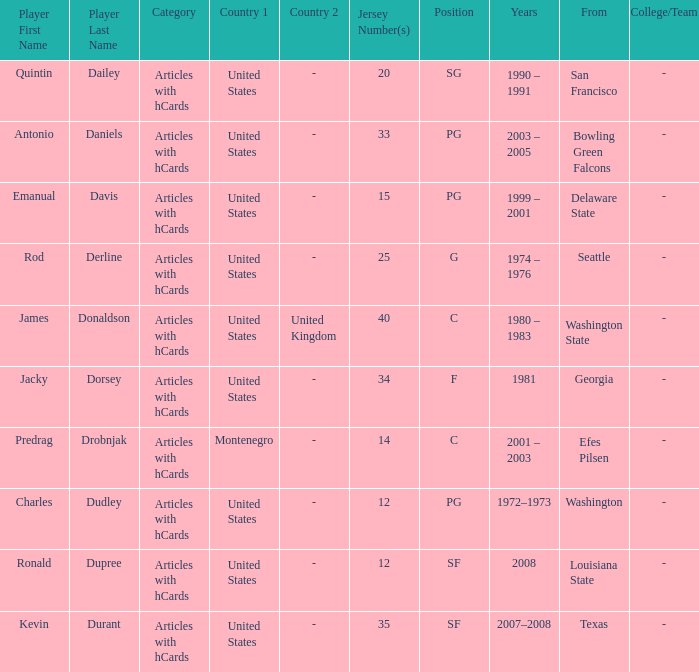What college was the player with the jersey number of 34 from? Georgia. 